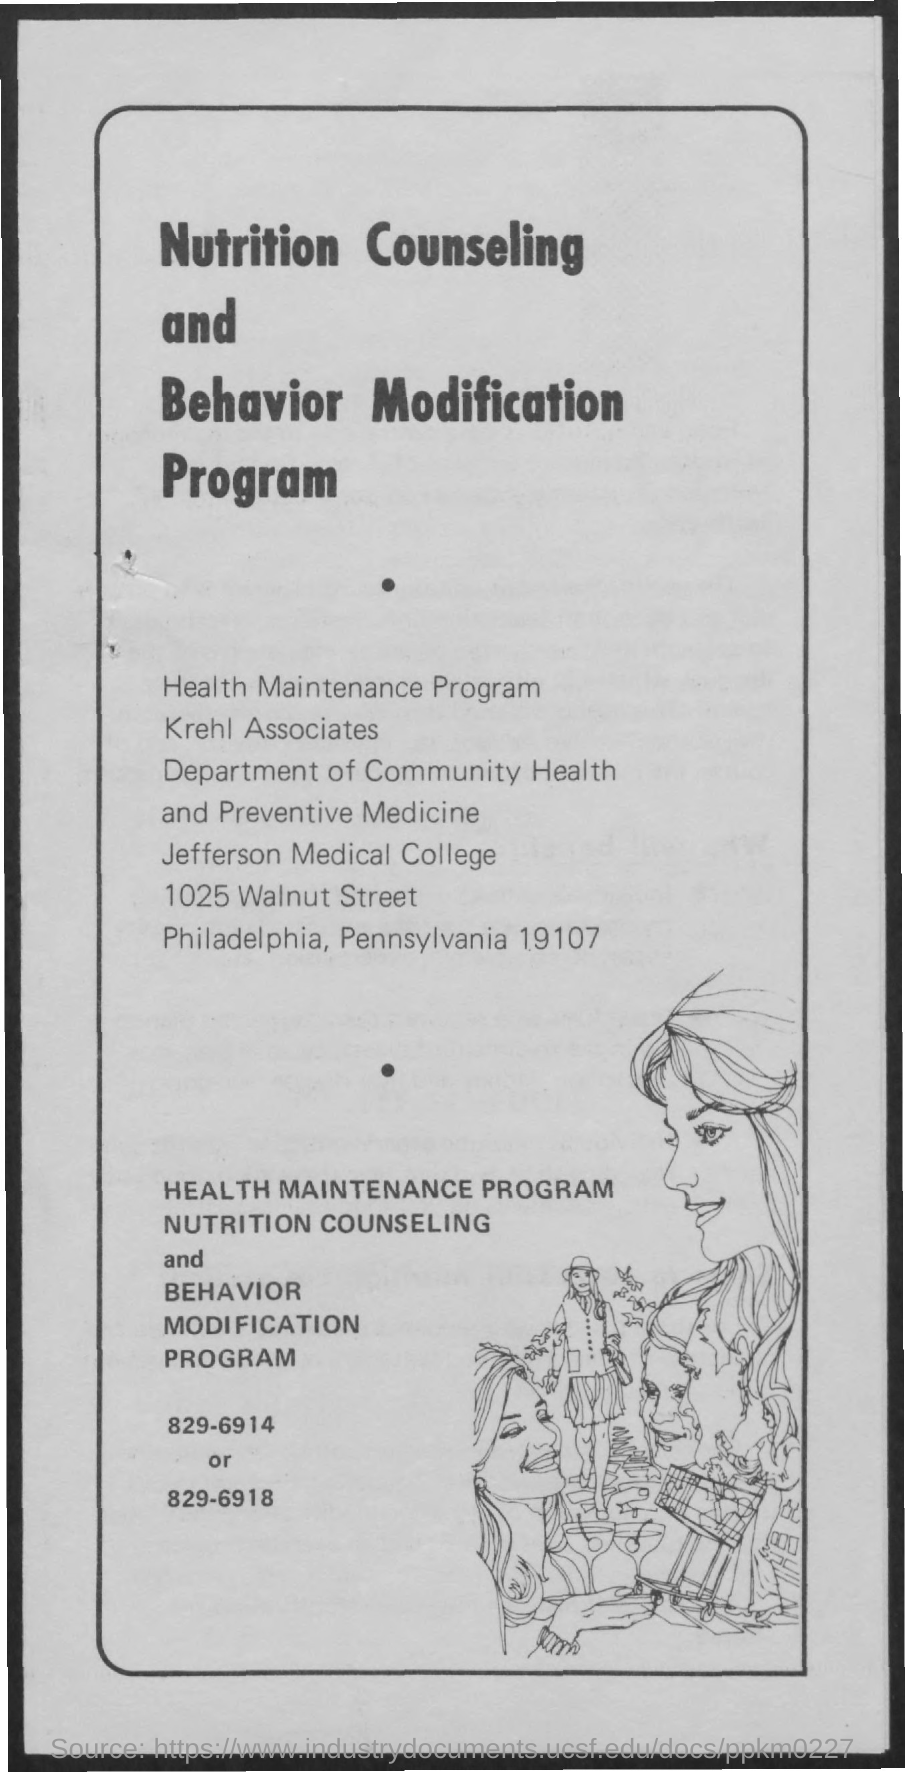Identify some key points in this picture. Jefferson Medical College is the name of a college that can be found on a page. The department mentioned on the given page is the Department of Community Health and Preventive Medicine. 